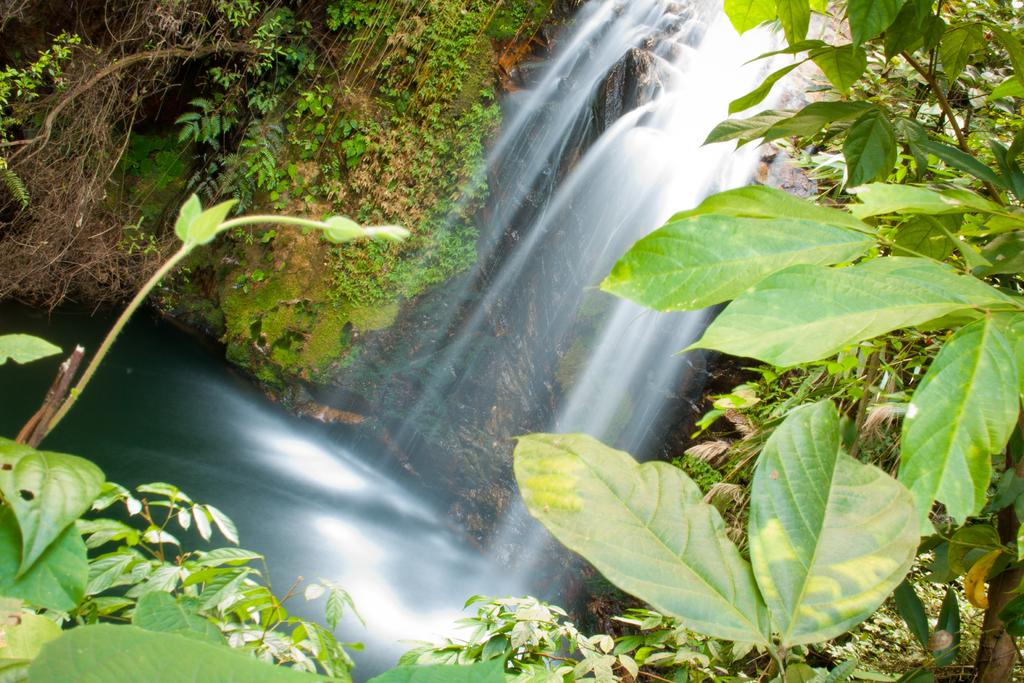What is the primary element visible in the image? There is water in the image. What types of vegetation can be seen in the image? There are plants and trees in the image. What type of machine is visible in the image? There is no machine present in the image; it features water, plants, and trees. What color is the can on the left side of the image? There is no can present in the image; it only contains water, plants, and trees. 